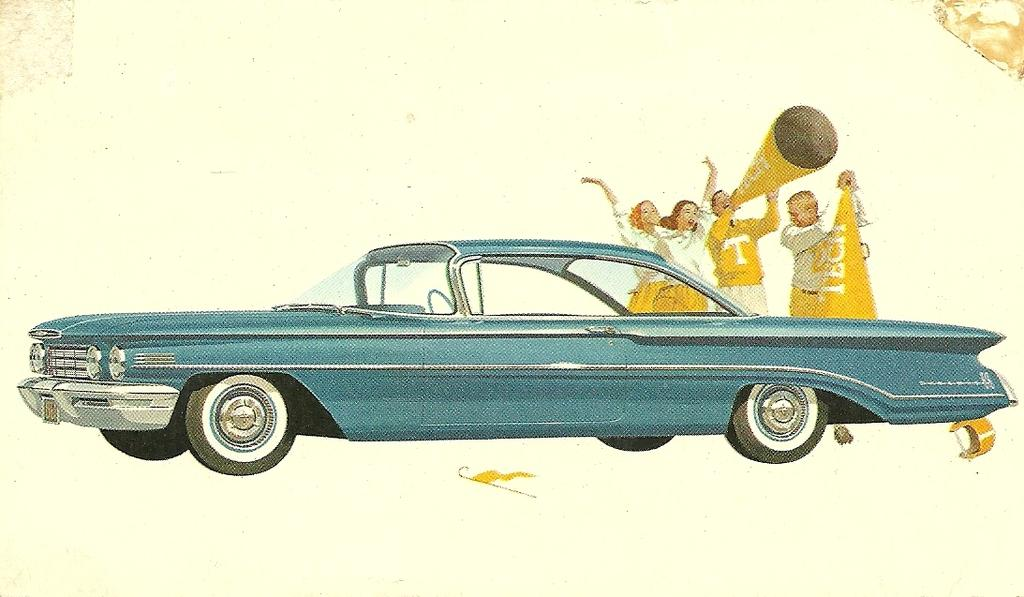What type of picture is in the image? The image contains a cartoon picture. What vehicle is present in the cartoon picture? There is a car in the cartoon picture. What are the people in the cartoon picture doing? The people are standing and holding cones in the cartoon picture. What protective gear is visible in the cartoon picture? A helmet is visible in the cartoon picture. What object is being used to hold something in the cartoon picture? There is a stick in the cartoon picture. What is the color of the background in the cartoon picture? The background of the cartoon picture is white. How many times did the people in the cartoon picture cry during the argument? There is no indication of an argument or crying in the cartoon picture; it simply shows people standing with cones and a car. 